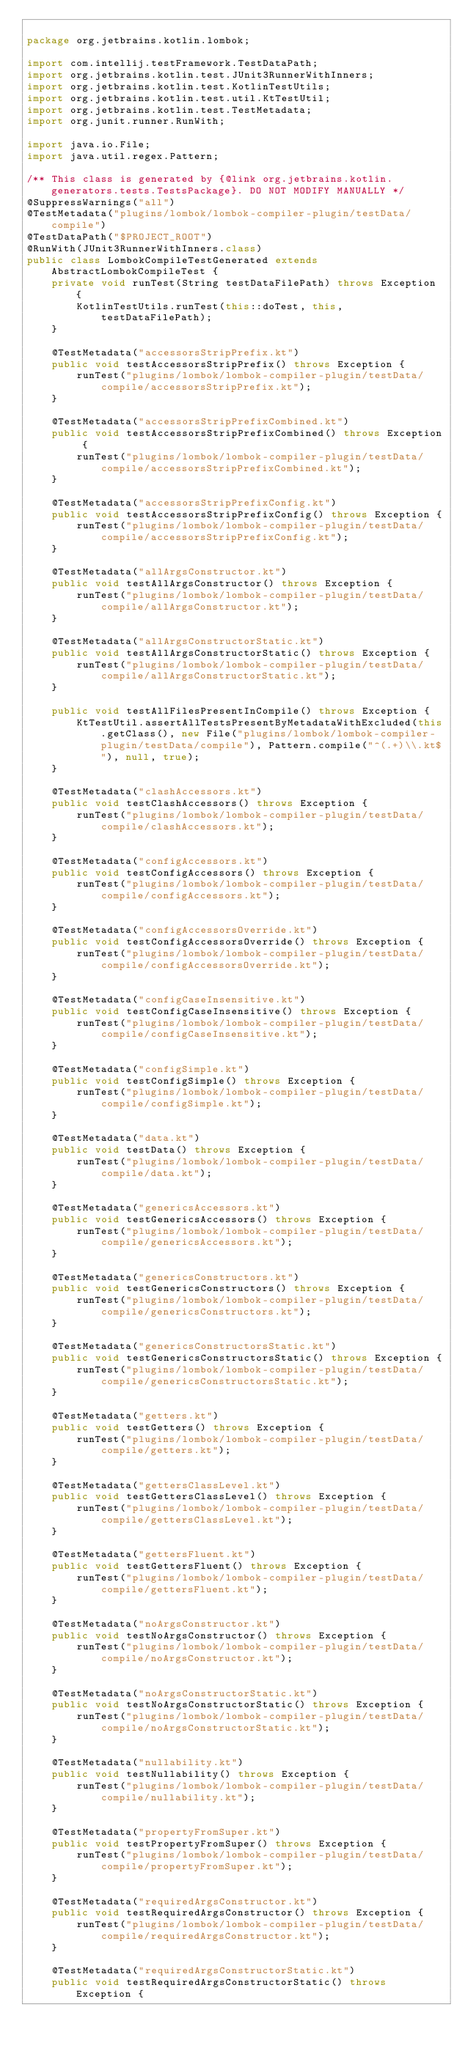<code> <loc_0><loc_0><loc_500><loc_500><_Java_>
package org.jetbrains.kotlin.lombok;

import com.intellij.testFramework.TestDataPath;
import org.jetbrains.kotlin.test.JUnit3RunnerWithInners;
import org.jetbrains.kotlin.test.KotlinTestUtils;
import org.jetbrains.kotlin.test.util.KtTestUtil;
import org.jetbrains.kotlin.test.TestMetadata;
import org.junit.runner.RunWith;

import java.io.File;
import java.util.regex.Pattern;

/** This class is generated by {@link org.jetbrains.kotlin.generators.tests.TestsPackage}. DO NOT MODIFY MANUALLY */
@SuppressWarnings("all")
@TestMetadata("plugins/lombok/lombok-compiler-plugin/testData/compile")
@TestDataPath("$PROJECT_ROOT")
@RunWith(JUnit3RunnerWithInners.class)
public class LombokCompileTestGenerated extends AbstractLombokCompileTest {
    private void runTest(String testDataFilePath) throws Exception {
        KotlinTestUtils.runTest(this::doTest, this, testDataFilePath);
    }

    @TestMetadata("accessorsStripPrefix.kt")
    public void testAccessorsStripPrefix() throws Exception {
        runTest("plugins/lombok/lombok-compiler-plugin/testData/compile/accessorsStripPrefix.kt");
    }

    @TestMetadata("accessorsStripPrefixCombined.kt")
    public void testAccessorsStripPrefixCombined() throws Exception {
        runTest("plugins/lombok/lombok-compiler-plugin/testData/compile/accessorsStripPrefixCombined.kt");
    }

    @TestMetadata("accessorsStripPrefixConfig.kt")
    public void testAccessorsStripPrefixConfig() throws Exception {
        runTest("plugins/lombok/lombok-compiler-plugin/testData/compile/accessorsStripPrefixConfig.kt");
    }

    @TestMetadata("allArgsConstructor.kt")
    public void testAllArgsConstructor() throws Exception {
        runTest("plugins/lombok/lombok-compiler-plugin/testData/compile/allArgsConstructor.kt");
    }

    @TestMetadata("allArgsConstructorStatic.kt")
    public void testAllArgsConstructorStatic() throws Exception {
        runTest("plugins/lombok/lombok-compiler-plugin/testData/compile/allArgsConstructorStatic.kt");
    }

    public void testAllFilesPresentInCompile() throws Exception {
        KtTestUtil.assertAllTestsPresentByMetadataWithExcluded(this.getClass(), new File("plugins/lombok/lombok-compiler-plugin/testData/compile"), Pattern.compile("^(.+)\\.kt$"), null, true);
    }

    @TestMetadata("clashAccessors.kt")
    public void testClashAccessors() throws Exception {
        runTest("plugins/lombok/lombok-compiler-plugin/testData/compile/clashAccessors.kt");
    }

    @TestMetadata("configAccessors.kt")
    public void testConfigAccessors() throws Exception {
        runTest("plugins/lombok/lombok-compiler-plugin/testData/compile/configAccessors.kt");
    }

    @TestMetadata("configAccessorsOverride.kt")
    public void testConfigAccessorsOverride() throws Exception {
        runTest("plugins/lombok/lombok-compiler-plugin/testData/compile/configAccessorsOverride.kt");
    }

    @TestMetadata("configCaseInsensitive.kt")
    public void testConfigCaseInsensitive() throws Exception {
        runTest("plugins/lombok/lombok-compiler-plugin/testData/compile/configCaseInsensitive.kt");
    }

    @TestMetadata("configSimple.kt")
    public void testConfigSimple() throws Exception {
        runTest("plugins/lombok/lombok-compiler-plugin/testData/compile/configSimple.kt");
    }

    @TestMetadata("data.kt")
    public void testData() throws Exception {
        runTest("plugins/lombok/lombok-compiler-plugin/testData/compile/data.kt");
    }

    @TestMetadata("genericsAccessors.kt")
    public void testGenericsAccessors() throws Exception {
        runTest("plugins/lombok/lombok-compiler-plugin/testData/compile/genericsAccessors.kt");
    }

    @TestMetadata("genericsConstructors.kt")
    public void testGenericsConstructors() throws Exception {
        runTest("plugins/lombok/lombok-compiler-plugin/testData/compile/genericsConstructors.kt");
    }

    @TestMetadata("genericsConstructorsStatic.kt")
    public void testGenericsConstructorsStatic() throws Exception {
        runTest("plugins/lombok/lombok-compiler-plugin/testData/compile/genericsConstructorsStatic.kt");
    }

    @TestMetadata("getters.kt")
    public void testGetters() throws Exception {
        runTest("plugins/lombok/lombok-compiler-plugin/testData/compile/getters.kt");
    }

    @TestMetadata("gettersClassLevel.kt")
    public void testGettersClassLevel() throws Exception {
        runTest("plugins/lombok/lombok-compiler-plugin/testData/compile/gettersClassLevel.kt");
    }

    @TestMetadata("gettersFluent.kt")
    public void testGettersFluent() throws Exception {
        runTest("plugins/lombok/lombok-compiler-plugin/testData/compile/gettersFluent.kt");
    }

    @TestMetadata("noArgsConstructor.kt")
    public void testNoArgsConstructor() throws Exception {
        runTest("plugins/lombok/lombok-compiler-plugin/testData/compile/noArgsConstructor.kt");
    }

    @TestMetadata("noArgsConstructorStatic.kt")
    public void testNoArgsConstructorStatic() throws Exception {
        runTest("plugins/lombok/lombok-compiler-plugin/testData/compile/noArgsConstructorStatic.kt");
    }

    @TestMetadata("nullability.kt")
    public void testNullability() throws Exception {
        runTest("plugins/lombok/lombok-compiler-plugin/testData/compile/nullability.kt");
    }

    @TestMetadata("propertyFromSuper.kt")
    public void testPropertyFromSuper() throws Exception {
        runTest("plugins/lombok/lombok-compiler-plugin/testData/compile/propertyFromSuper.kt");
    }

    @TestMetadata("requiredArgsConstructor.kt")
    public void testRequiredArgsConstructor() throws Exception {
        runTest("plugins/lombok/lombok-compiler-plugin/testData/compile/requiredArgsConstructor.kt");
    }

    @TestMetadata("requiredArgsConstructorStatic.kt")
    public void testRequiredArgsConstructorStatic() throws Exception {</code> 